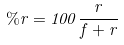Convert formula to latex. <formula><loc_0><loc_0><loc_500><loc_500>\% r = 1 0 0 \frac { r } { f + r }</formula> 